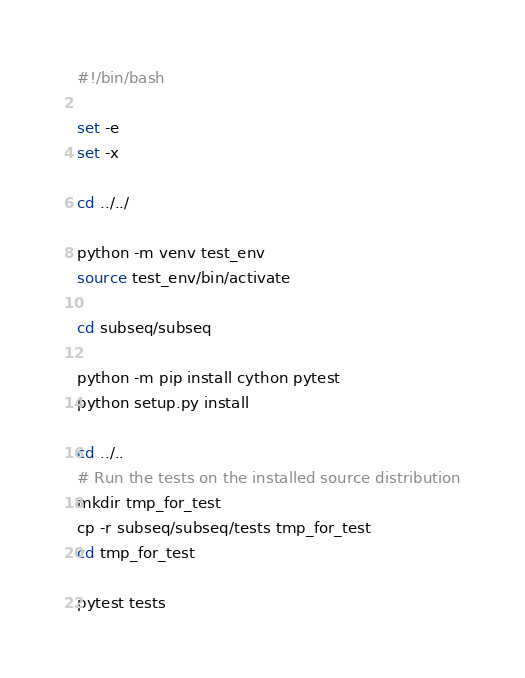Convert code to text. <code><loc_0><loc_0><loc_500><loc_500><_Bash_>#!/bin/bash

set -e
set -x

cd ../../

python -m venv test_env
source test_env/bin/activate

cd subseq/subseq

python -m pip install cython pytest
python setup.py install

cd ../..
# Run the tests on the installed source distribution
mkdir tmp_for_test
cp -r subseq/subseq/tests tmp_for_test
cd tmp_for_test

pytest tests
</code> 